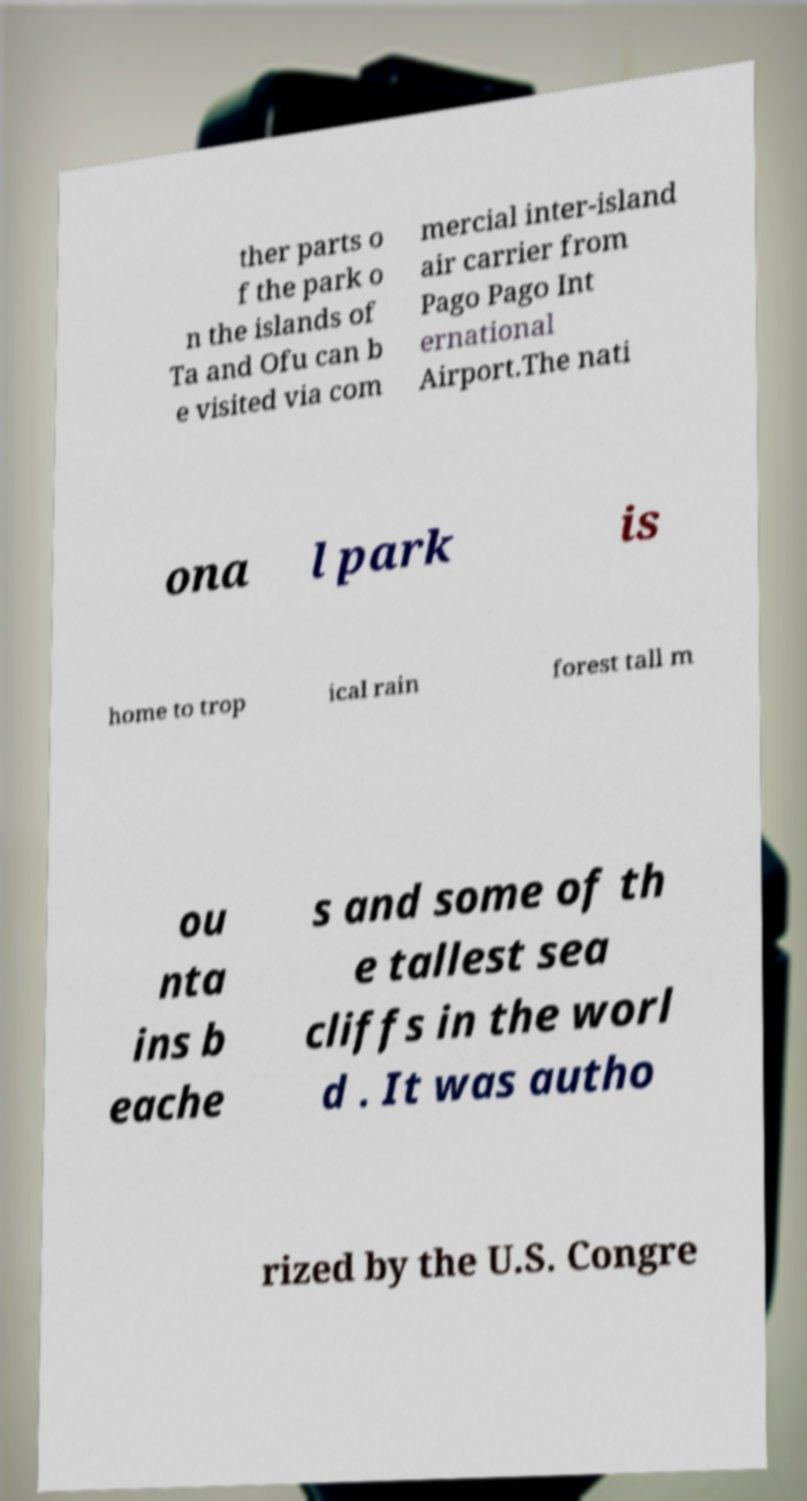I need the written content from this picture converted into text. Can you do that? ther parts o f the park o n the islands of Ta and Ofu can b e visited via com mercial inter-island air carrier from Pago Pago Int ernational Airport.The nati ona l park is home to trop ical rain forest tall m ou nta ins b eache s and some of th e tallest sea cliffs in the worl d . It was autho rized by the U.S. Congre 